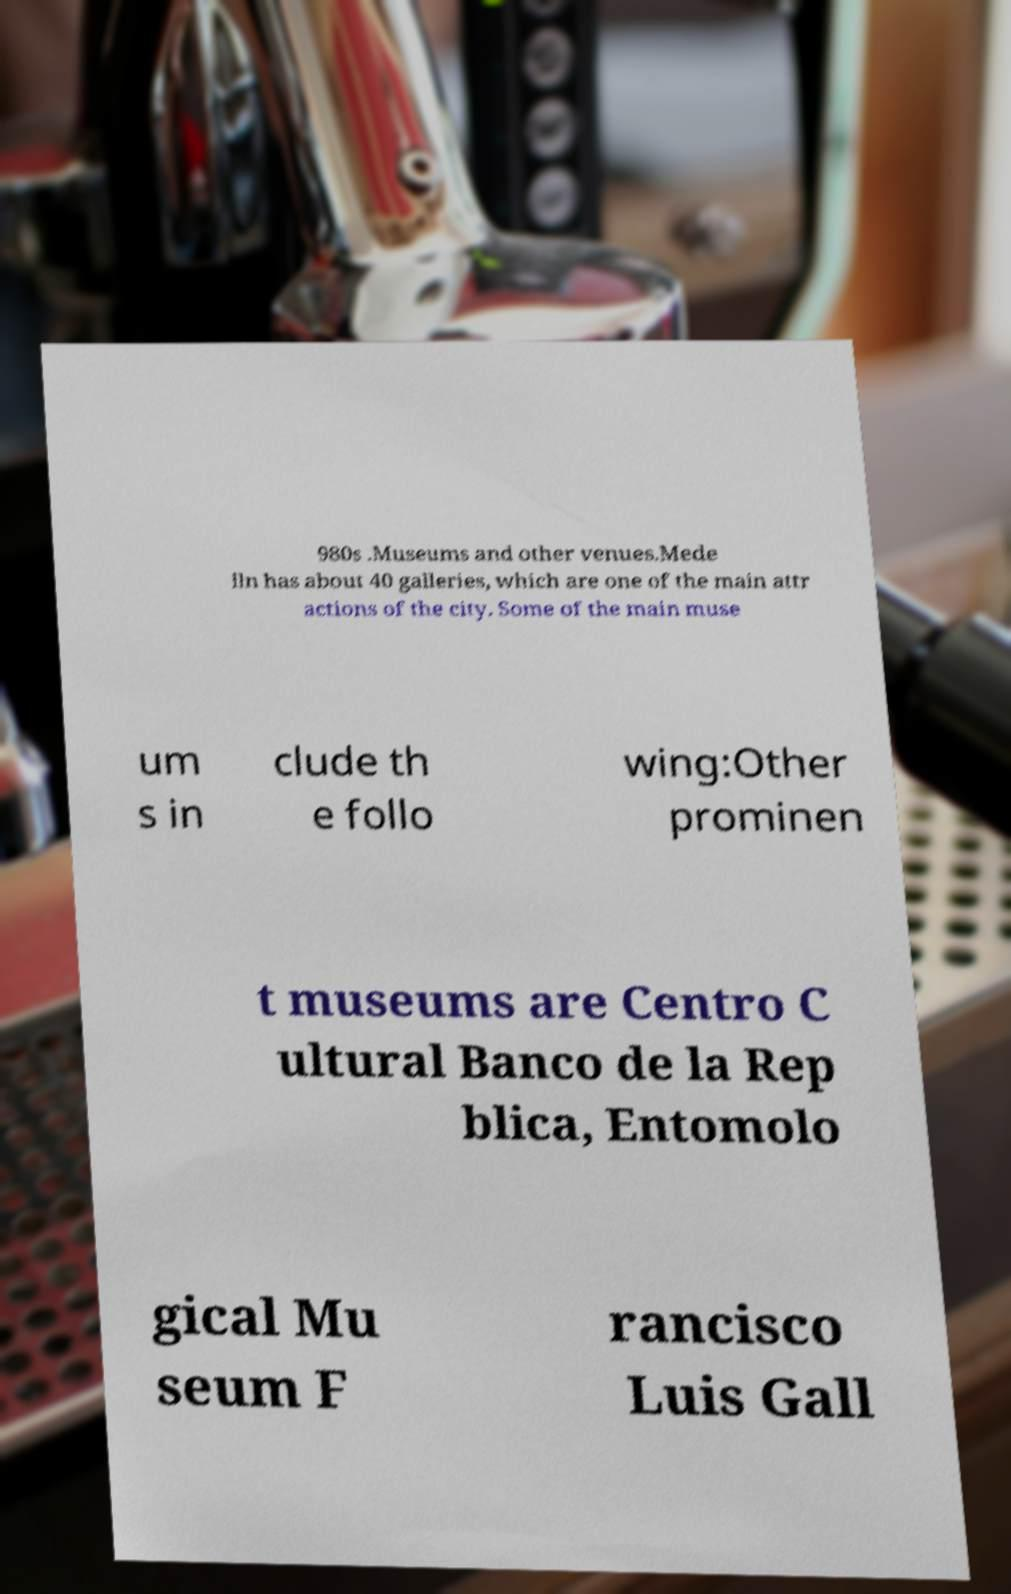Can you read and provide the text displayed in the image?This photo seems to have some interesting text. Can you extract and type it out for me? 980s .Museums and other venues.Mede lln has about 40 galleries, which are one of the main attr actions of the city. Some of the main muse um s in clude th e follo wing:Other prominen t museums are Centro C ultural Banco de la Rep blica, Entomolo gical Mu seum F rancisco Luis Gall 